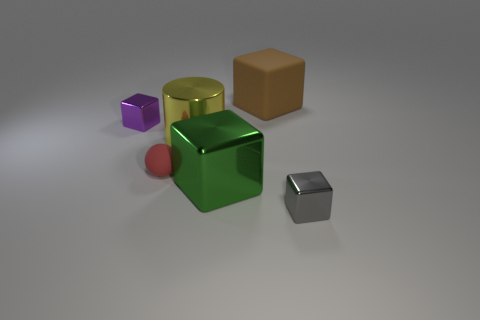What material is the large object behind the big thing that is to the left of the big cube left of the brown thing?
Provide a succinct answer. Rubber. What is the material of the brown block?
Keep it short and to the point. Rubber. What size is the other gray thing that is the same shape as the large rubber thing?
Your answer should be very brief. Small. Does the rubber ball have the same color as the metallic cylinder?
Provide a short and direct response. No. What number of other things are there of the same material as the large brown object
Make the answer very short. 1. Are there the same number of yellow metal cylinders that are behind the brown matte block and blue metallic cubes?
Provide a short and direct response. Yes. There is a object to the right of the brown rubber thing; is it the same size as the large brown block?
Offer a very short reply. No. How many tiny metal cubes are on the right side of the big rubber cube?
Keep it short and to the point. 1. What material is the big thing that is to the left of the matte block and to the right of the yellow cylinder?
Your answer should be compact. Metal. How many big things are either purple spheres or purple shiny cubes?
Provide a succinct answer. 0. 